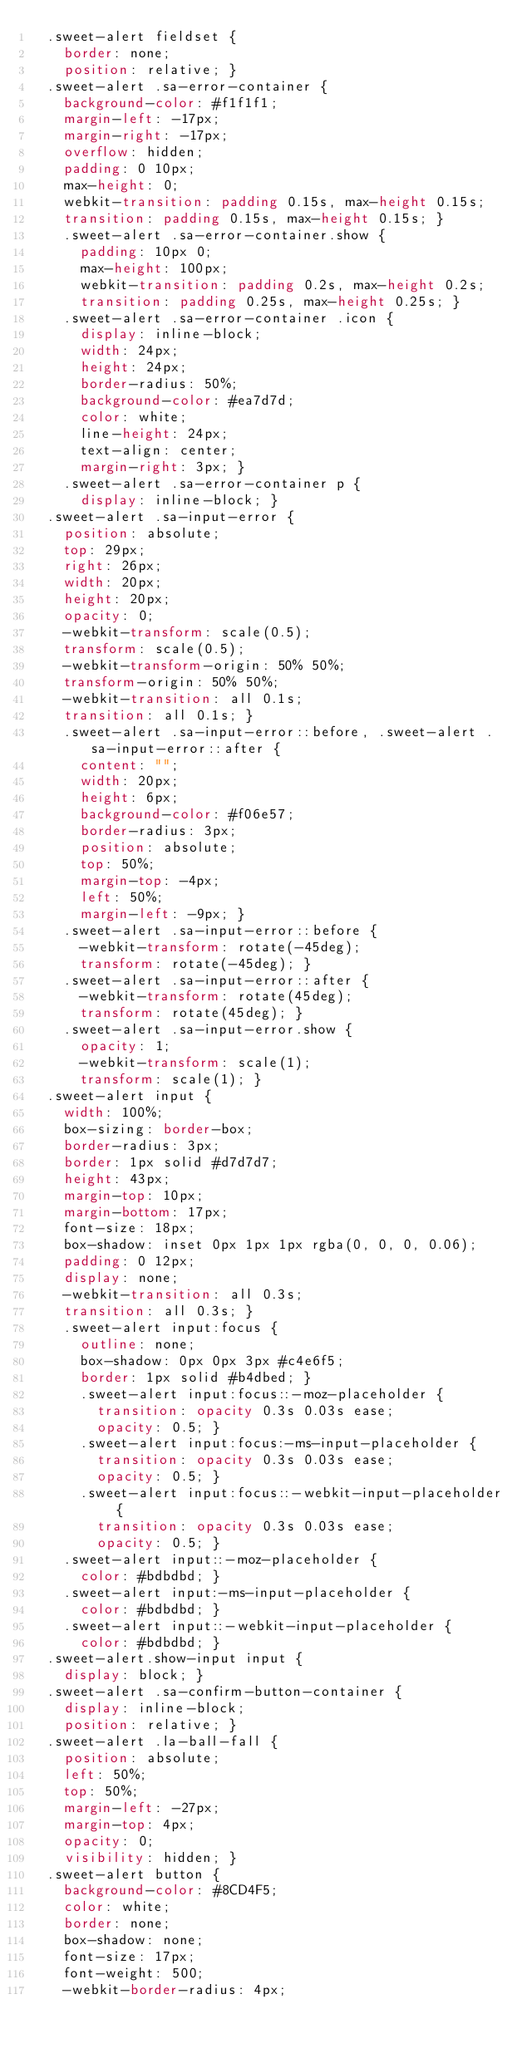Convert code to text. <code><loc_0><loc_0><loc_500><loc_500><_CSS_>  .sweet-alert fieldset {
    border: none;
    position: relative; }
  .sweet-alert .sa-error-container {
    background-color: #f1f1f1;
    margin-left: -17px;
    margin-right: -17px;
    overflow: hidden;
    padding: 0 10px;
    max-height: 0;
    webkit-transition: padding 0.15s, max-height 0.15s;
    transition: padding 0.15s, max-height 0.15s; }
    .sweet-alert .sa-error-container.show {
      padding: 10px 0;
      max-height: 100px;
      webkit-transition: padding 0.2s, max-height 0.2s;
      transition: padding 0.25s, max-height 0.25s; }
    .sweet-alert .sa-error-container .icon {
      display: inline-block;
      width: 24px;
      height: 24px;
      border-radius: 50%;
      background-color: #ea7d7d;
      color: white;
      line-height: 24px;
      text-align: center;
      margin-right: 3px; }
    .sweet-alert .sa-error-container p {
      display: inline-block; }
  .sweet-alert .sa-input-error {
    position: absolute;
    top: 29px;
    right: 26px;
    width: 20px;
    height: 20px;
    opacity: 0;
    -webkit-transform: scale(0.5);
    transform: scale(0.5);
    -webkit-transform-origin: 50% 50%;
    transform-origin: 50% 50%;
    -webkit-transition: all 0.1s;
    transition: all 0.1s; }
    .sweet-alert .sa-input-error::before, .sweet-alert .sa-input-error::after {
      content: "";
      width: 20px;
      height: 6px;
      background-color: #f06e57;
      border-radius: 3px;
      position: absolute;
      top: 50%;
      margin-top: -4px;
      left: 50%;
      margin-left: -9px; }
    .sweet-alert .sa-input-error::before {
      -webkit-transform: rotate(-45deg);
      transform: rotate(-45deg); }
    .sweet-alert .sa-input-error::after {
      -webkit-transform: rotate(45deg);
      transform: rotate(45deg); }
    .sweet-alert .sa-input-error.show {
      opacity: 1;
      -webkit-transform: scale(1);
      transform: scale(1); }
  .sweet-alert input {
    width: 100%;
    box-sizing: border-box;
    border-radius: 3px;
    border: 1px solid #d7d7d7;
    height: 43px;
    margin-top: 10px;
    margin-bottom: 17px;
    font-size: 18px;
    box-shadow: inset 0px 1px 1px rgba(0, 0, 0, 0.06);
    padding: 0 12px;
    display: none;
    -webkit-transition: all 0.3s;
    transition: all 0.3s; }
    .sweet-alert input:focus {
      outline: none;
      box-shadow: 0px 0px 3px #c4e6f5;
      border: 1px solid #b4dbed; }
      .sweet-alert input:focus::-moz-placeholder {
        transition: opacity 0.3s 0.03s ease;
        opacity: 0.5; }
      .sweet-alert input:focus:-ms-input-placeholder {
        transition: opacity 0.3s 0.03s ease;
        opacity: 0.5; }
      .sweet-alert input:focus::-webkit-input-placeholder {
        transition: opacity 0.3s 0.03s ease;
        opacity: 0.5; }
    .sweet-alert input::-moz-placeholder {
      color: #bdbdbd; }
    .sweet-alert input:-ms-input-placeholder {
      color: #bdbdbd; }
    .sweet-alert input::-webkit-input-placeholder {
      color: #bdbdbd; }
  .sweet-alert.show-input input {
    display: block; }
  .sweet-alert .sa-confirm-button-container {
    display: inline-block;
    position: relative; }
  .sweet-alert .la-ball-fall {
    position: absolute;
    left: 50%;
    top: 50%;
    margin-left: -27px;
    margin-top: 4px;
    opacity: 0;
    visibility: hidden; }
  .sweet-alert button {
    background-color: #8CD4F5;
    color: white;
    border: none;
    box-shadow: none;
    font-size: 17px;
    font-weight: 500;
    -webkit-border-radius: 4px;</code> 